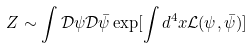Convert formula to latex. <formula><loc_0><loc_0><loc_500><loc_500>Z \sim \int \mathcal { D } \psi \mathcal { D } \bar { \psi } \exp [ \int d ^ { 4 } x \mathcal { L } ( \psi , \bar { \psi } ) ]</formula> 